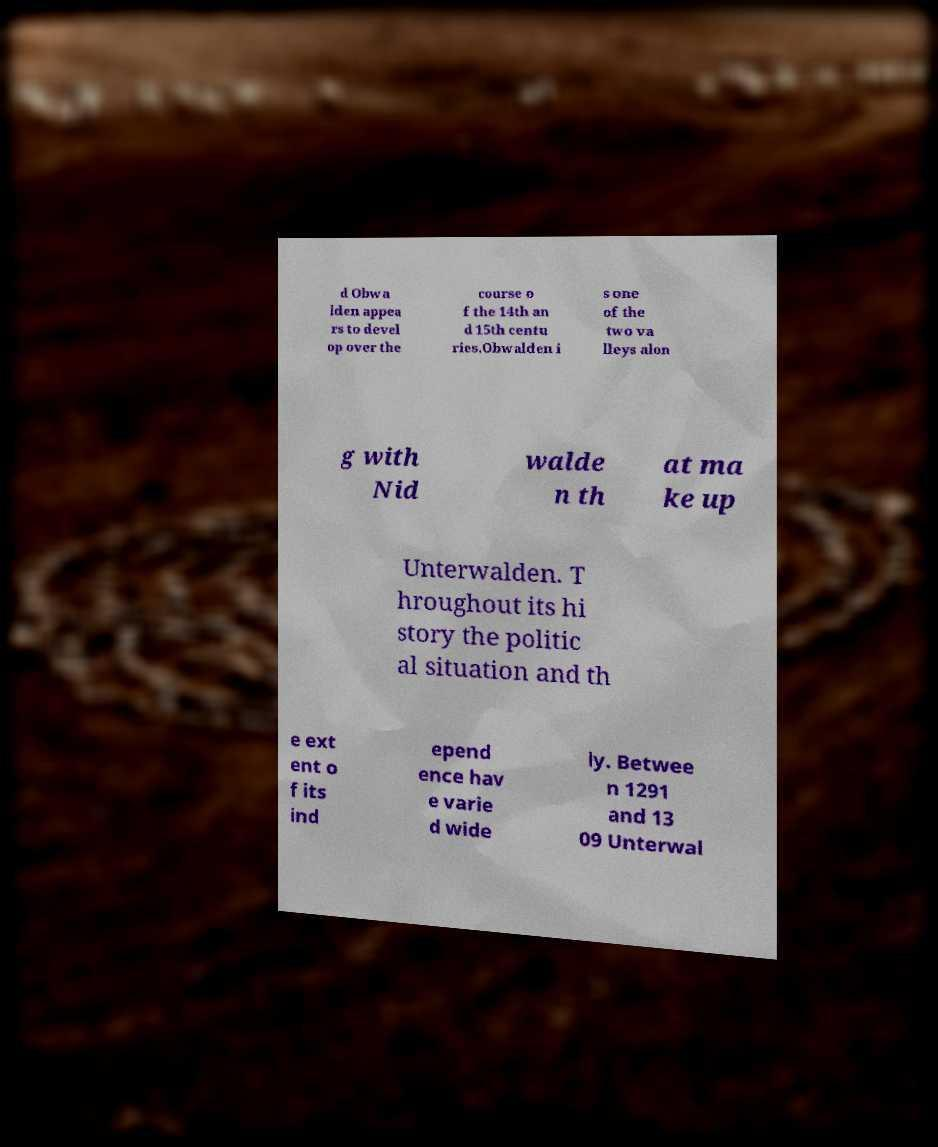For documentation purposes, I need the text within this image transcribed. Could you provide that? d Obwa lden appea rs to devel op over the course o f the 14th an d 15th centu ries.Obwalden i s one of the two va lleys alon g with Nid walde n th at ma ke up Unterwalden. T hroughout its hi story the politic al situation and th e ext ent o f its ind epend ence hav e varie d wide ly. Betwee n 1291 and 13 09 Unterwal 